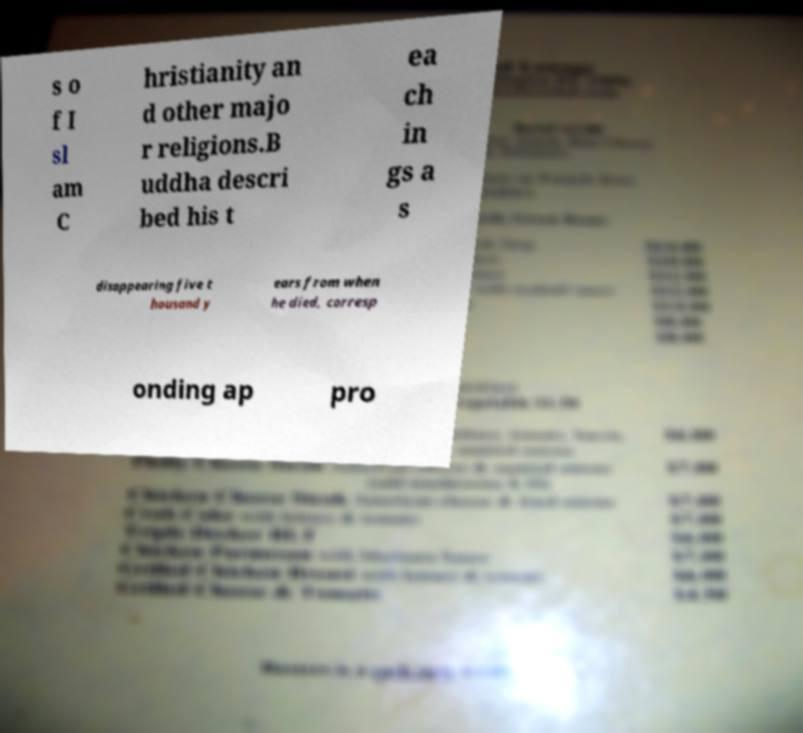Can you accurately transcribe the text from the provided image for me? s o f I sl am C hristianity an d other majo r religions.B uddha descri bed his t ea ch in gs a s disappearing five t housand y ears from when he died, corresp onding ap pro 